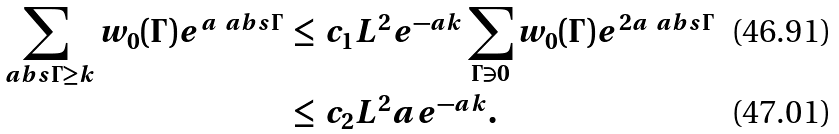<formula> <loc_0><loc_0><loc_500><loc_500>\sum _ { \ a b s { \Gamma } \geq k } w _ { 0 } ( \Gamma ) e ^ { a \ a b s { \Gamma } } \, & \leq \, c _ { 1 } L ^ { 2 } e ^ { - a k } \sum _ { \Gamma \ni 0 } w _ { 0 } ( \Gamma ) e ^ { 2 a \ a b s { \Gamma } } \\ & \leq \, c _ { 2 } L ^ { 2 } a e ^ { - a k } .</formula> 